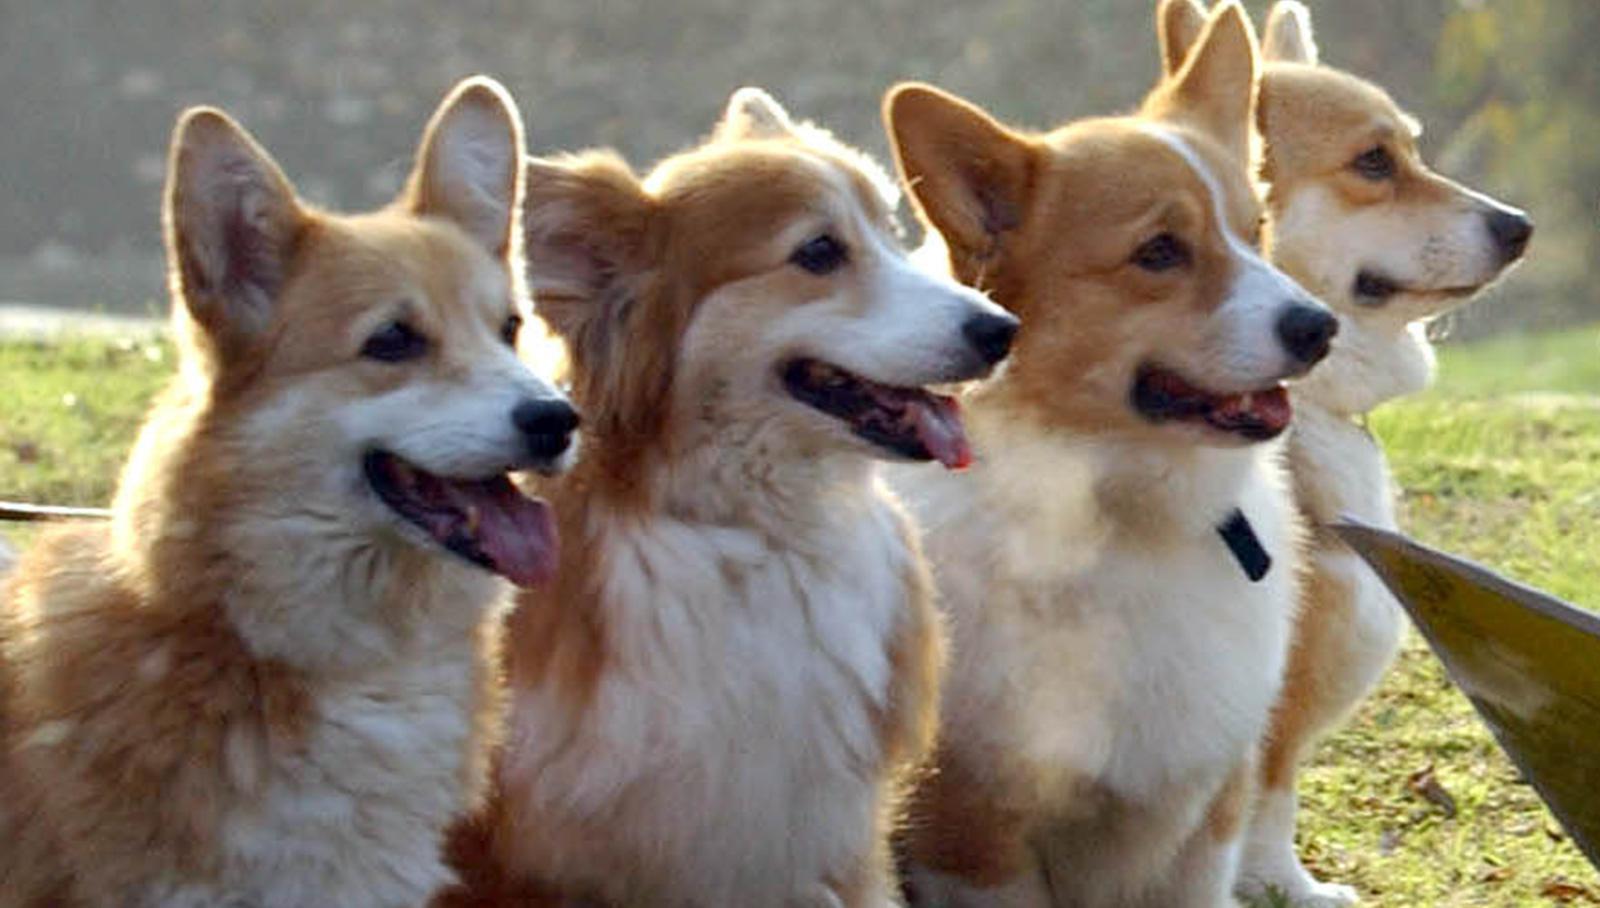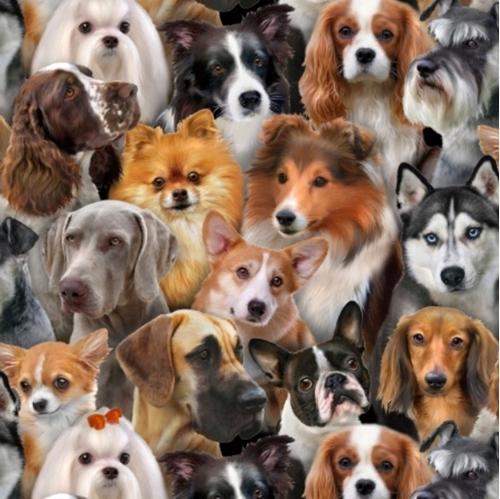The first image is the image on the left, the second image is the image on the right. For the images displayed, is the sentence "Less than four corgis are in the pair." factually correct? Answer yes or no. No. The first image is the image on the left, the second image is the image on the right. Analyze the images presented: Is the assertion "The right image contains at least two dogs." valid? Answer yes or no. Yes. 